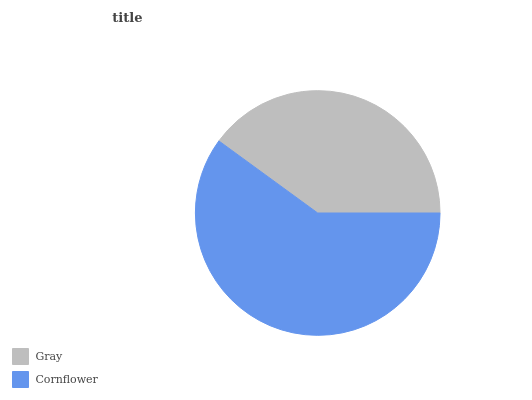Is Gray the minimum?
Answer yes or no. Yes. Is Cornflower the maximum?
Answer yes or no. Yes. Is Cornflower the minimum?
Answer yes or no. No. Is Cornflower greater than Gray?
Answer yes or no. Yes. Is Gray less than Cornflower?
Answer yes or no. Yes. Is Gray greater than Cornflower?
Answer yes or no. No. Is Cornflower less than Gray?
Answer yes or no. No. Is Cornflower the high median?
Answer yes or no. Yes. Is Gray the low median?
Answer yes or no. Yes. Is Gray the high median?
Answer yes or no. No. Is Cornflower the low median?
Answer yes or no. No. 